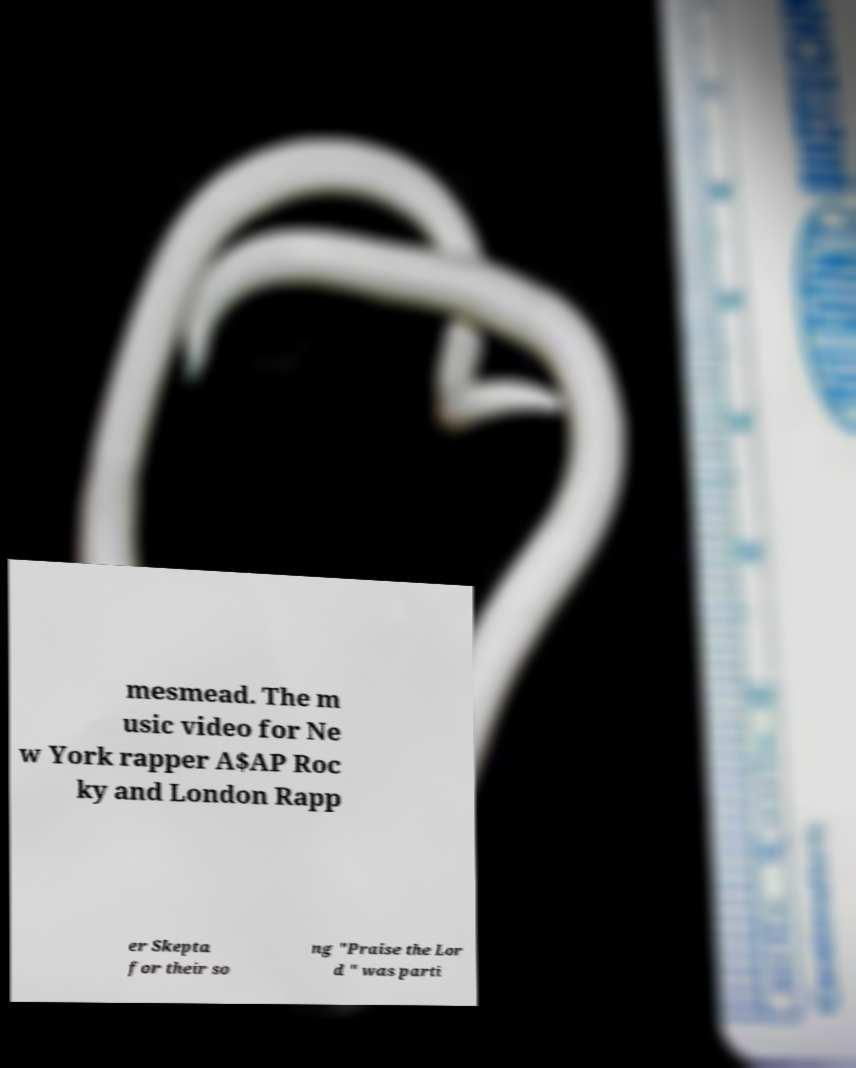I need the written content from this picture converted into text. Can you do that? mesmead. The m usic video for Ne w York rapper A$AP Roc ky and London Rapp er Skepta for their so ng "Praise the Lor d " was parti 